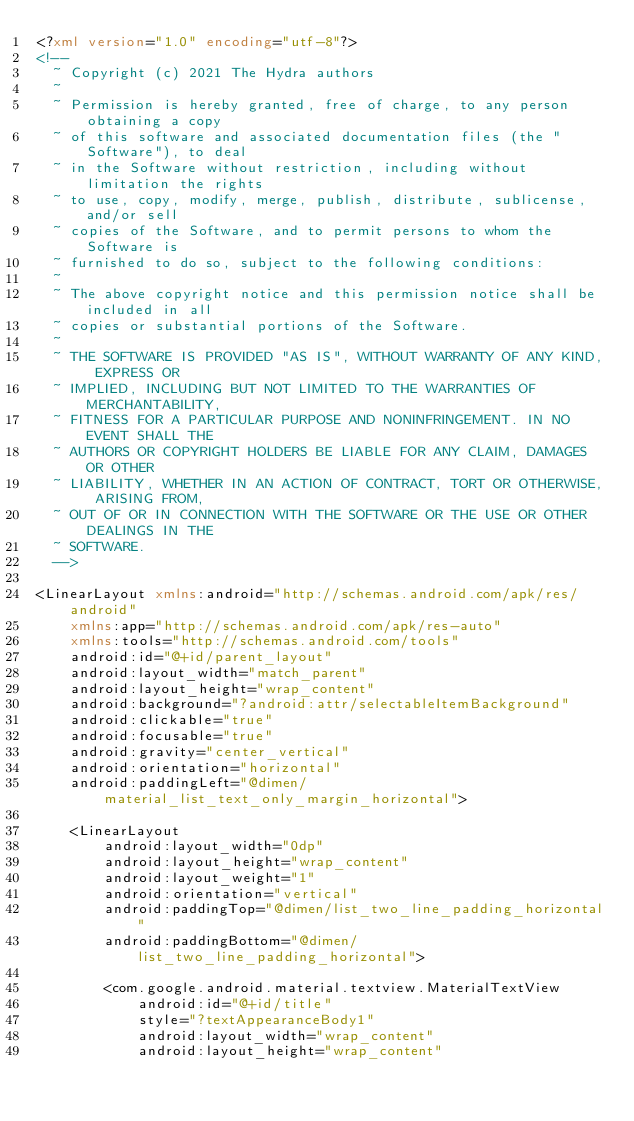<code> <loc_0><loc_0><loc_500><loc_500><_XML_><?xml version="1.0" encoding="utf-8"?>
<!--
  ~ Copyright (c) 2021 The Hydra authors
  ~
  ~ Permission is hereby granted, free of charge, to any person obtaining a copy
  ~ of this software and associated documentation files (the "Software"), to deal
  ~ in the Software without restriction, including without limitation the rights
  ~ to use, copy, modify, merge, publish, distribute, sublicense, and/or sell
  ~ copies of the Software, and to permit persons to whom the Software is
  ~ furnished to do so, subject to the following conditions:
  ~
  ~ The above copyright notice and this permission notice shall be included in all
  ~ copies or substantial portions of the Software.
  ~
  ~ THE SOFTWARE IS PROVIDED "AS IS", WITHOUT WARRANTY OF ANY KIND, EXPRESS OR
  ~ IMPLIED, INCLUDING BUT NOT LIMITED TO THE WARRANTIES OF MERCHANTABILITY,
  ~ FITNESS FOR A PARTICULAR PURPOSE AND NONINFRINGEMENT. IN NO EVENT SHALL THE
  ~ AUTHORS OR COPYRIGHT HOLDERS BE LIABLE FOR ANY CLAIM, DAMAGES OR OTHER
  ~ LIABILITY, WHETHER IN AN ACTION OF CONTRACT, TORT OR OTHERWISE, ARISING FROM,
  ~ OUT OF OR IN CONNECTION WITH THE SOFTWARE OR THE USE OR OTHER DEALINGS IN THE
  ~ SOFTWARE.
  -->

<LinearLayout xmlns:android="http://schemas.android.com/apk/res/android"
    xmlns:app="http://schemas.android.com/apk/res-auto"
    xmlns:tools="http://schemas.android.com/tools"
    android:id="@+id/parent_layout"
    android:layout_width="match_parent"
    android:layout_height="wrap_content"
    android:background="?android:attr/selectableItemBackground"
    android:clickable="true"
    android:focusable="true"
    android:gravity="center_vertical"
    android:orientation="horizontal"
    android:paddingLeft="@dimen/material_list_text_only_margin_horizontal">

    <LinearLayout
        android:layout_width="0dp"
        android:layout_height="wrap_content"
        android:layout_weight="1"
        android:orientation="vertical"
        android:paddingTop="@dimen/list_two_line_padding_horizontal"
        android:paddingBottom="@dimen/list_two_line_padding_horizontal">

        <com.google.android.material.textview.MaterialTextView
            android:id="@+id/title"
            style="?textAppearanceBody1"
            android:layout_width="wrap_content"
            android:layout_height="wrap_content"</code> 